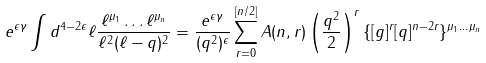<formula> <loc_0><loc_0><loc_500><loc_500>e ^ { \epsilon \gamma } \int d ^ { 4 - 2 \epsilon } \ell \frac { \ell ^ { \mu _ { 1 } } \dots \ell ^ { \mu _ { n } } } { \ell ^ { 2 } ( \ell - q ) ^ { 2 } } = \frac { e ^ { \epsilon \gamma } } { ( q ^ { 2 } ) ^ { \epsilon } } \sum _ { r = 0 } ^ { [ n / 2 ] } A ( n , r ) \left ( \frac { q ^ { 2 } } { 2 } \right ) ^ { r } \{ [ g ] ^ { r } [ q ] ^ { n - 2 r } \} ^ { \mu _ { 1 } \dots \mu _ { n } }</formula> 